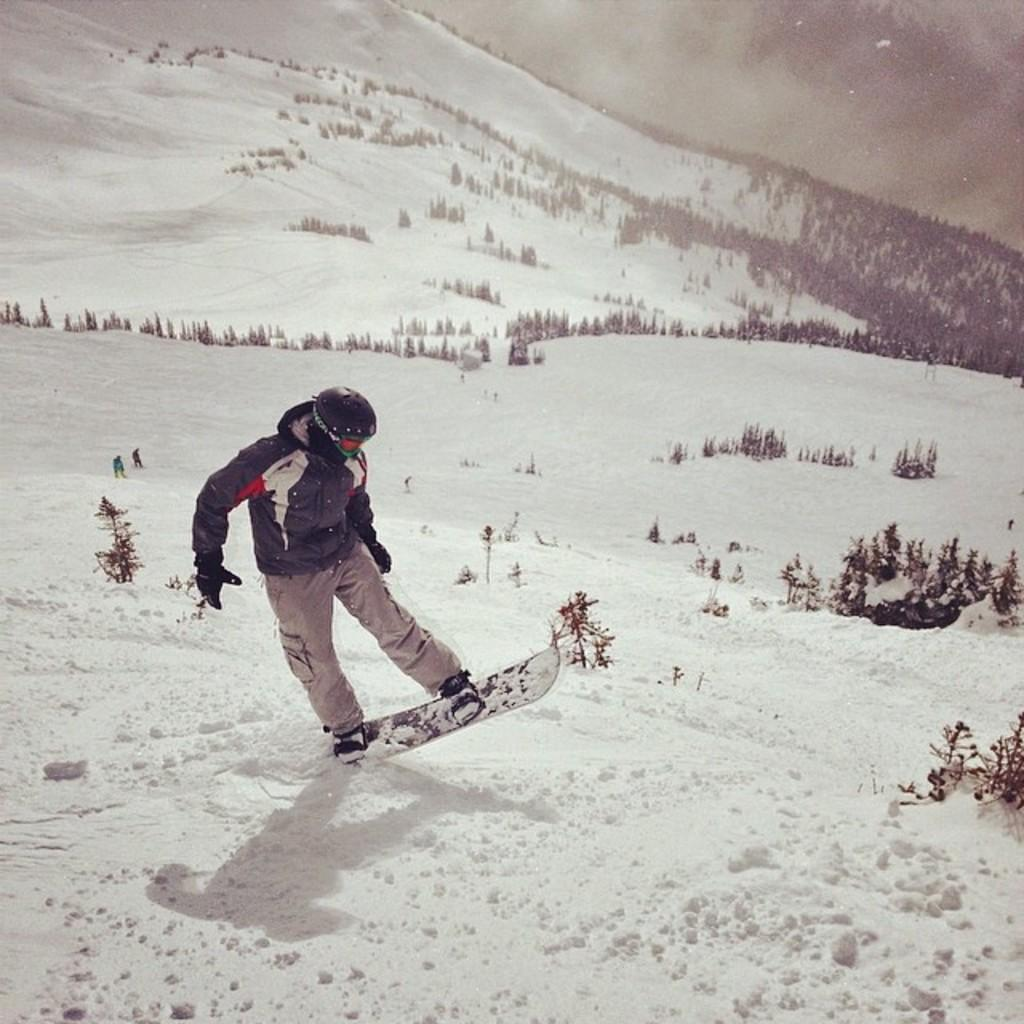What activity is the person in the image engaged in? The person is skiing in the image. What surface is the person skiing on? The person is skiing on snow. What can be seen in the background of the image? There are trees in the background of the image. What is the condition of the ground in the image? There is snow on the ground in the image. What type of tub can be seen in the image? There is no tub present in the image; it features a person skiing on snow. Can you describe the stranger in the image? There is no stranger present in the image; it only shows a person skiing. 